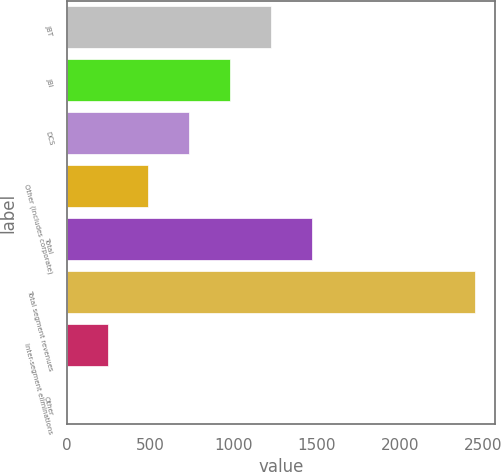Convert chart to OTSL. <chart><loc_0><loc_0><loc_500><loc_500><bar_chart><fcel>JBT<fcel>JBI<fcel>DCS<fcel>Other (includes corporate)<fcel>Total<fcel>Total segment revenues<fcel>Inter-segment eliminations<fcel>Other<nl><fcel>1224.5<fcel>979.8<fcel>735.1<fcel>490.4<fcel>1469.2<fcel>2448<fcel>245.7<fcel>1<nl></chart> 